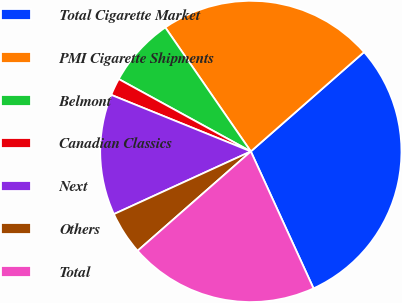<chart> <loc_0><loc_0><loc_500><loc_500><pie_chart><fcel>Total Cigarette Market<fcel>PMI Cigarette Shipments<fcel>Belmont<fcel>Canadian Classics<fcel>Next<fcel>Others<fcel>Total<nl><fcel>29.63%<fcel>23.15%<fcel>7.41%<fcel>1.85%<fcel>12.96%<fcel>4.63%<fcel>20.37%<nl></chart> 